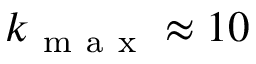Convert formula to latex. <formula><loc_0><loc_0><loc_500><loc_500>k _ { m a x } \approx 1 0</formula> 